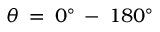Convert formula to latex. <formula><loc_0><loc_0><loc_500><loc_500>\theta \, = \, 0 ^ { \circ } \, - \, 1 8 0 ^ { \circ }</formula> 